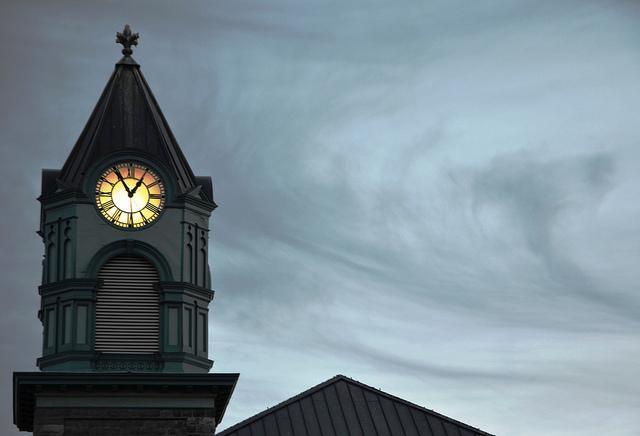How many clocks are in the picture?
Give a very brief answer. 1. 